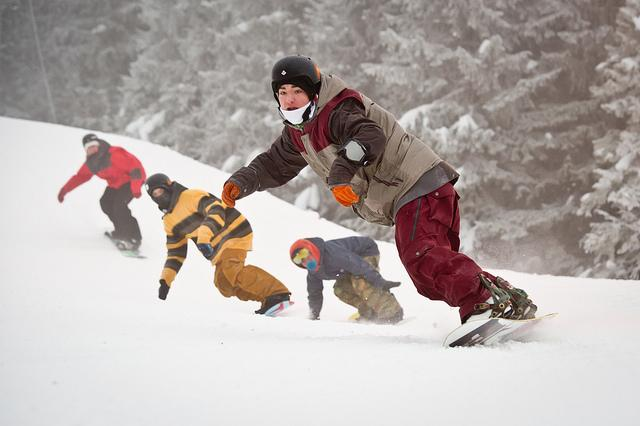Why are the men leaning to one side? balance 